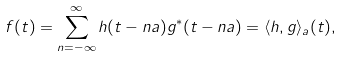<formula> <loc_0><loc_0><loc_500><loc_500>f ( t ) = \sum _ { n = - \infty } ^ { \infty } h ( t - n a ) g ^ { \ast } ( t - n a ) = \langle h , g \rangle _ { a } ( t ) ,</formula> 